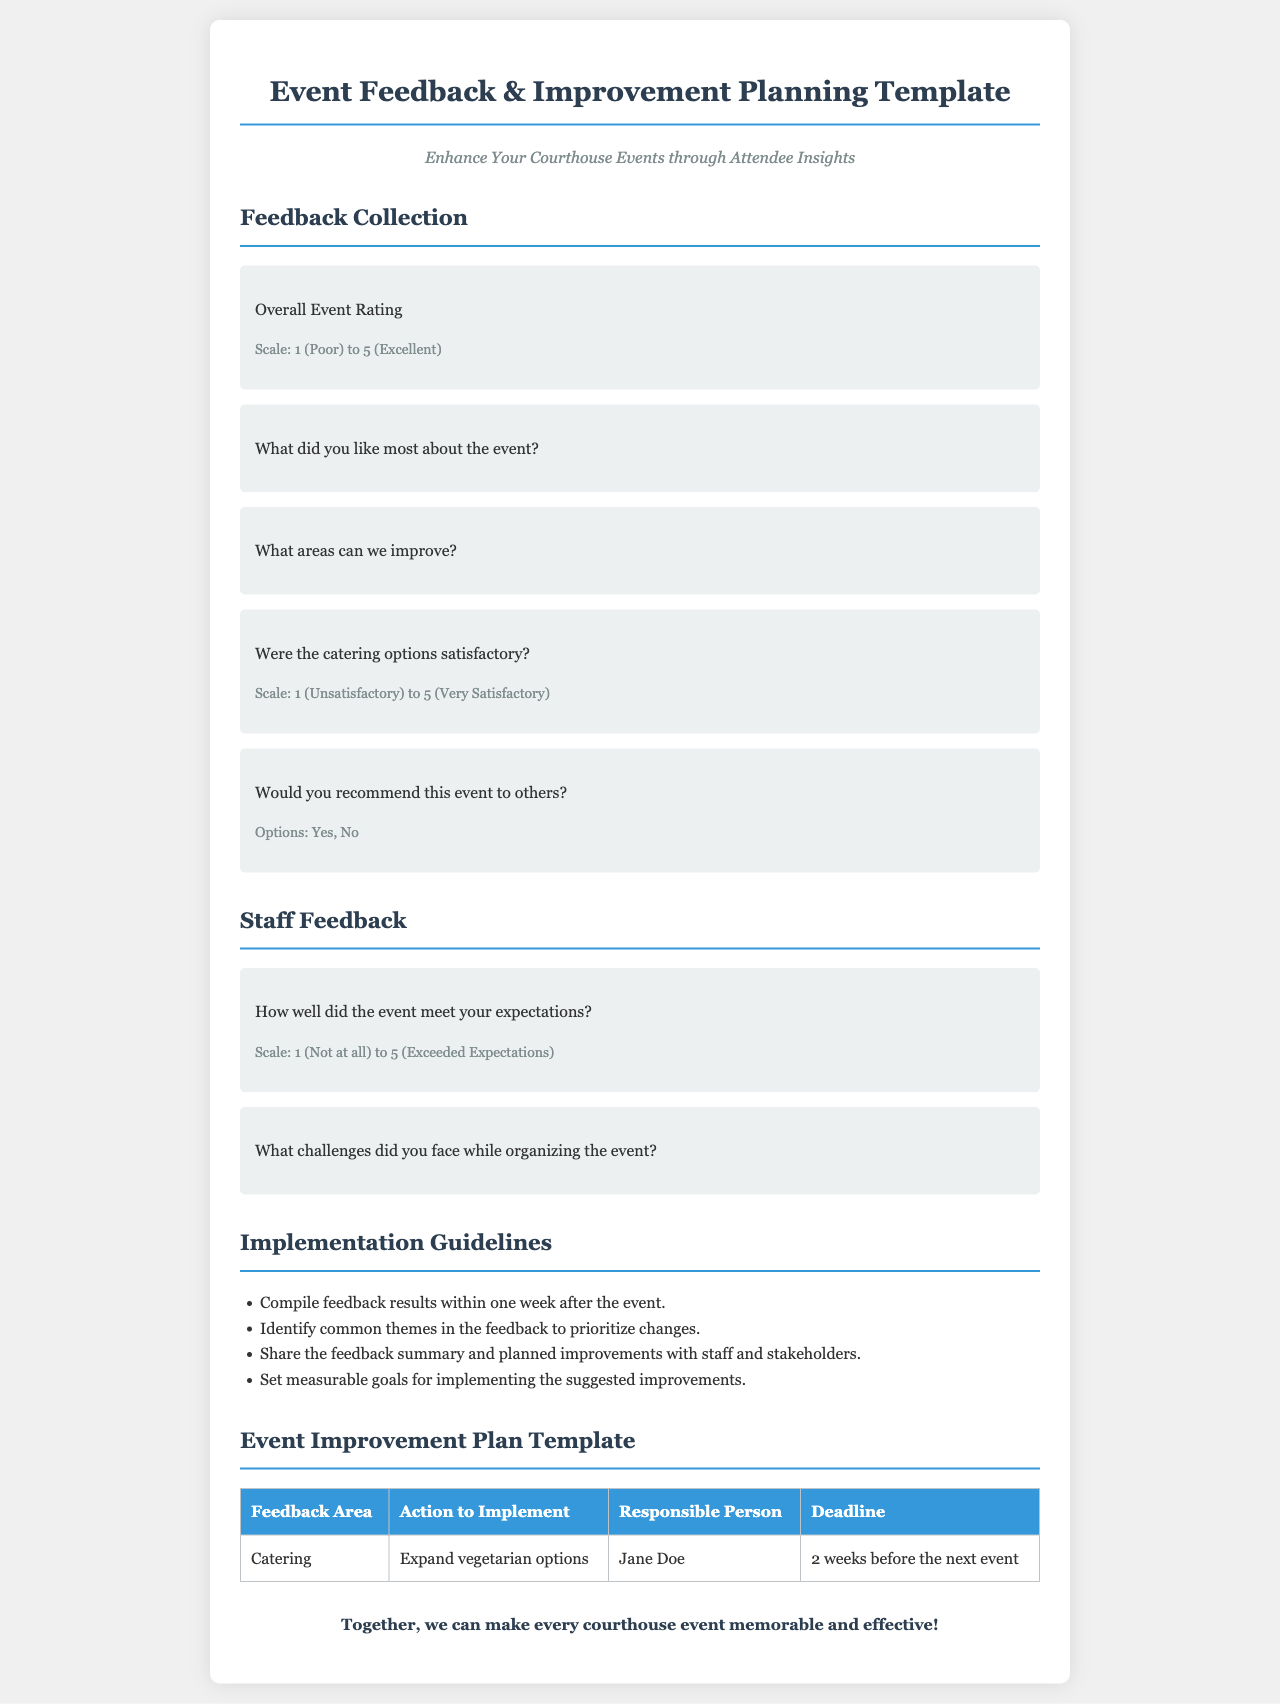what is the title of the brochure? The title of the brochure is displayed prominently at the top of the document.
Answer: Event Feedback & Improvement Planning Template what is the maximum rating scale for overall event rating? The document specifies a rating scale for the overall event rating.
Answer: 5 what section contains questions for staff feedback? The document is organized into sections that discuss different types of feedback.
Answer: Staff Feedback who is responsible for expanding vegetarian options? The document provides a table with action items and responsible individuals for event improvements.
Answer: Jane Doe how many guidelines are listed for implementation? The section on Implementation Guidelines contains a list of actionable points.
Answer: 4 what is the lowest rating for catering options? The document features a rating scale for the catering options.
Answer: 1 what is the timeframe to compile feedback results after the event? The guidelines outline specific timelines for tasks related to feedback collection.
Answer: one week what type of feedback does the document aim to collect? The brochure is designed to gather certain insights from event attendees.
Answer: Event Feedback what are the possible responses to the question about recommending the event? The options for this question are clearly stated in the brochure.
Answer: Yes, No 